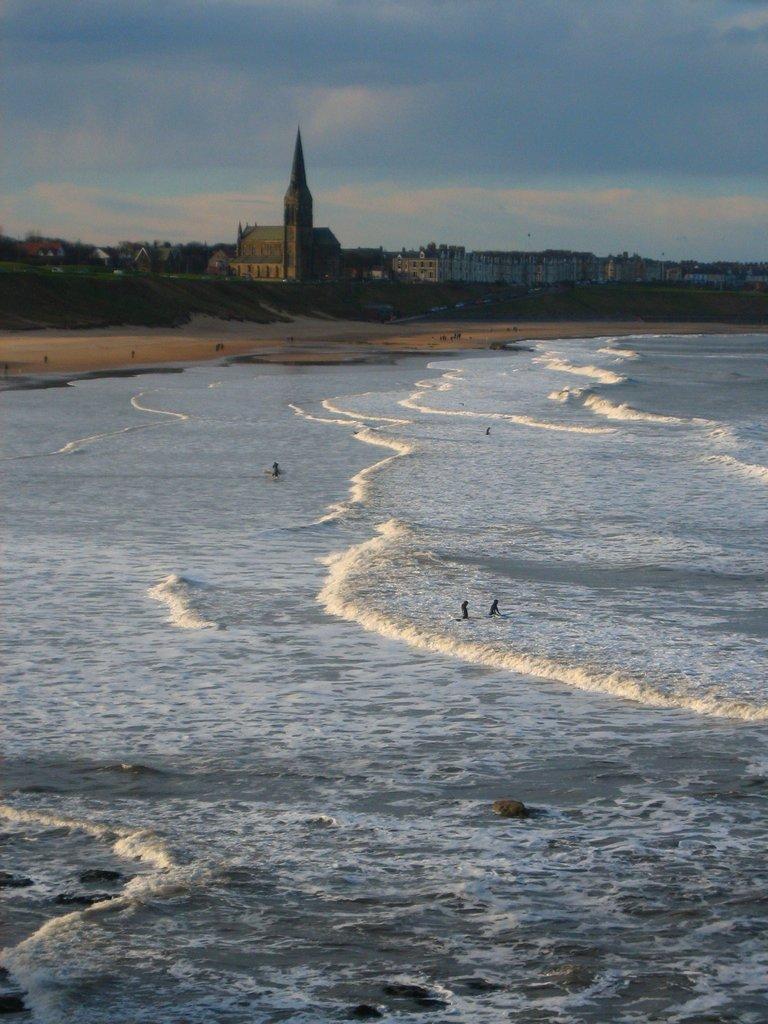In one or two sentences, can you explain what this image depicts? In this image we can see persons on sea and seashore, piles of sand, trees, buildings and sky with clouds. 